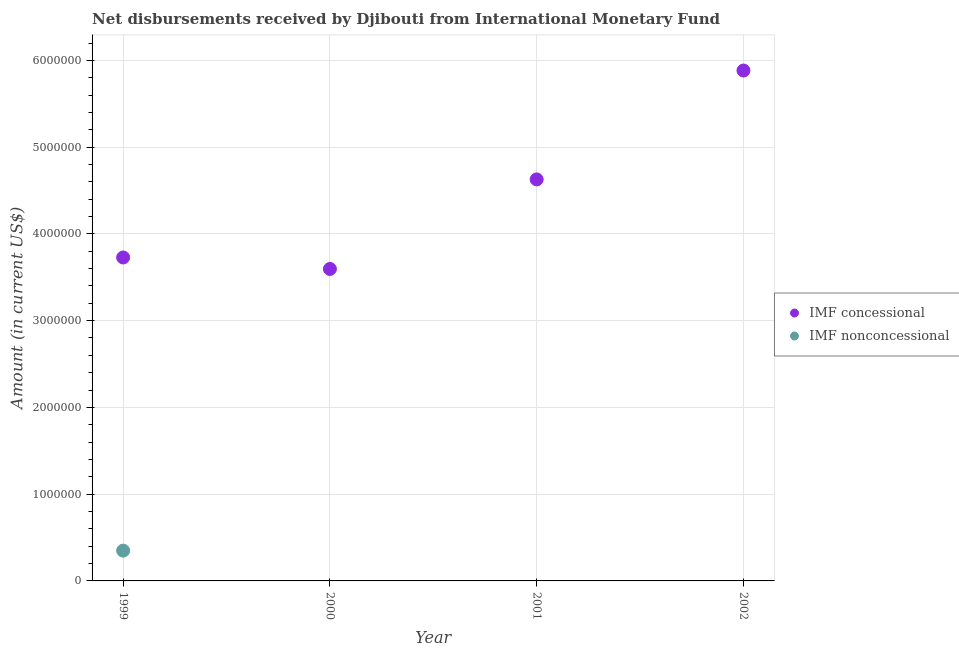Is the number of dotlines equal to the number of legend labels?
Make the answer very short. No. What is the net concessional disbursements from imf in 2000?
Ensure brevity in your answer.  3.60e+06. Across all years, what is the maximum net concessional disbursements from imf?
Provide a short and direct response. 5.88e+06. Across all years, what is the minimum net concessional disbursements from imf?
Keep it short and to the point. 3.60e+06. In which year was the net non concessional disbursements from imf maximum?
Your response must be concise. 1999. What is the total net non concessional disbursements from imf in the graph?
Your answer should be compact. 3.49e+05. What is the difference between the net concessional disbursements from imf in 2000 and that in 2002?
Provide a succinct answer. -2.29e+06. What is the difference between the net concessional disbursements from imf in 2001 and the net non concessional disbursements from imf in 2000?
Your response must be concise. 4.63e+06. What is the average net non concessional disbursements from imf per year?
Your response must be concise. 8.72e+04. In the year 1999, what is the difference between the net non concessional disbursements from imf and net concessional disbursements from imf?
Keep it short and to the point. -3.38e+06. What is the ratio of the net concessional disbursements from imf in 2001 to that in 2002?
Offer a terse response. 0.79. What is the difference between the highest and the second highest net concessional disbursements from imf?
Ensure brevity in your answer.  1.26e+06. What is the difference between the highest and the lowest net non concessional disbursements from imf?
Your response must be concise. 3.49e+05. In how many years, is the net non concessional disbursements from imf greater than the average net non concessional disbursements from imf taken over all years?
Provide a short and direct response. 1. Does the net non concessional disbursements from imf monotonically increase over the years?
Make the answer very short. No. Is the net concessional disbursements from imf strictly less than the net non concessional disbursements from imf over the years?
Offer a terse response. No. How many dotlines are there?
Provide a short and direct response. 2. What is the difference between two consecutive major ticks on the Y-axis?
Your answer should be very brief. 1.00e+06. Does the graph contain any zero values?
Ensure brevity in your answer.  Yes. Does the graph contain grids?
Your answer should be very brief. Yes. Where does the legend appear in the graph?
Give a very brief answer. Center right. How many legend labels are there?
Offer a very short reply. 2. How are the legend labels stacked?
Make the answer very short. Vertical. What is the title of the graph?
Offer a terse response. Net disbursements received by Djibouti from International Monetary Fund. What is the label or title of the X-axis?
Your answer should be very brief. Year. What is the Amount (in current US$) of IMF concessional in 1999?
Your answer should be very brief. 3.73e+06. What is the Amount (in current US$) in IMF nonconcessional in 1999?
Offer a terse response. 3.49e+05. What is the Amount (in current US$) of IMF concessional in 2000?
Your answer should be compact. 3.60e+06. What is the Amount (in current US$) of IMF concessional in 2001?
Offer a terse response. 4.63e+06. What is the Amount (in current US$) of IMF concessional in 2002?
Offer a terse response. 5.88e+06. What is the Amount (in current US$) of IMF nonconcessional in 2002?
Ensure brevity in your answer.  0. Across all years, what is the maximum Amount (in current US$) in IMF concessional?
Offer a terse response. 5.88e+06. Across all years, what is the maximum Amount (in current US$) of IMF nonconcessional?
Offer a very short reply. 3.49e+05. Across all years, what is the minimum Amount (in current US$) in IMF concessional?
Your answer should be very brief. 3.60e+06. Across all years, what is the minimum Amount (in current US$) in IMF nonconcessional?
Offer a very short reply. 0. What is the total Amount (in current US$) in IMF concessional in the graph?
Your answer should be very brief. 1.78e+07. What is the total Amount (in current US$) of IMF nonconcessional in the graph?
Ensure brevity in your answer.  3.49e+05. What is the difference between the Amount (in current US$) of IMF concessional in 1999 and that in 2000?
Your answer should be compact. 1.32e+05. What is the difference between the Amount (in current US$) in IMF concessional in 1999 and that in 2001?
Provide a succinct answer. -9.00e+05. What is the difference between the Amount (in current US$) of IMF concessional in 1999 and that in 2002?
Provide a succinct answer. -2.16e+06. What is the difference between the Amount (in current US$) of IMF concessional in 2000 and that in 2001?
Ensure brevity in your answer.  -1.03e+06. What is the difference between the Amount (in current US$) in IMF concessional in 2000 and that in 2002?
Your answer should be compact. -2.29e+06. What is the difference between the Amount (in current US$) of IMF concessional in 2001 and that in 2002?
Provide a short and direct response. -1.26e+06. What is the average Amount (in current US$) in IMF concessional per year?
Provide a succinct answer. 4.46e+06. What is the average Amount (in current US$) in IMF nonconcessional per year?
Offer a very short reply. 8.72e+04. In the year 1999, what is the difference between the Amount (in current US$) in IMF concessional and Amount (in current US$) in IMF nonconcessional?
Your response must be concise. 3.38e+06. What is the ratio of the Amount (in current US$) of IMF concessional in 1999 to that in 2000?
Give a very brief answer. 1.04. What is the ratio of the Amount (in current US$) in IMF concessional in 1999 to that in 2001?
Ensure brevity in your answer.  0.81. What is the ratio of the Amount (in current US$) in IMF concessional in 1999 to that in 2002?
Provide a short and direct response. 0.63. What is the ratio of the Amount (in current US$) of IMF concessional in 2000 to that in 2001?
Ensure brevity in your answer.  0.78. What is the ratio of the Amount (in current US$) in IMF concessional in 2000 to that in 2002?
Ensure brevity in your answer.  0.61. What is the ratio of the Amount (in current US$) of IMF concessional in 2001 to that in 2002?
Provide a succinct answer. 0.79. What is the difference between the highest and the second highest Amount (in current US$) of IMF concessional?
Make the answer very short. 1.26e+06. What is the difference between the highest and the lowest Amount (in current US$) of IMF concessional?
Your response must be concise. 2.29e+06. What is the difference between the highest and the lowest Amount (in current US$) in IMF nonconcessional?
Your answer should be very brief. 3.49e+05. 